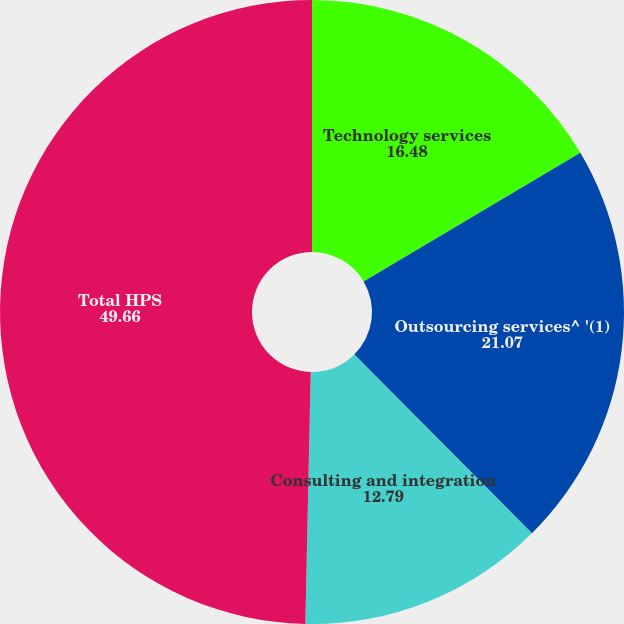Convert chart. <chart><loc_0><loc_0><loc_500><loc_500><pie_chart><fcel>Technology services<fcel>Outsourcing services^ '(1)<fcel>Consulting and integration<fcel>Total HPS<nl><fcel>16.48%<fcel>21.07%<fcel>12.79%<fcel>49.66%<nl></chart> 